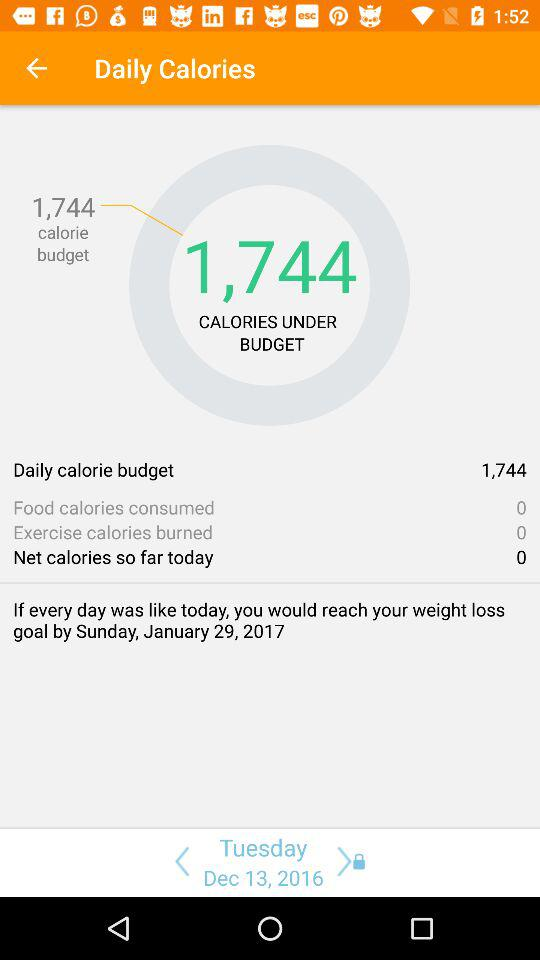What is the total number of food calories that are consumed? The total number of food calories that are consumed is 0. 